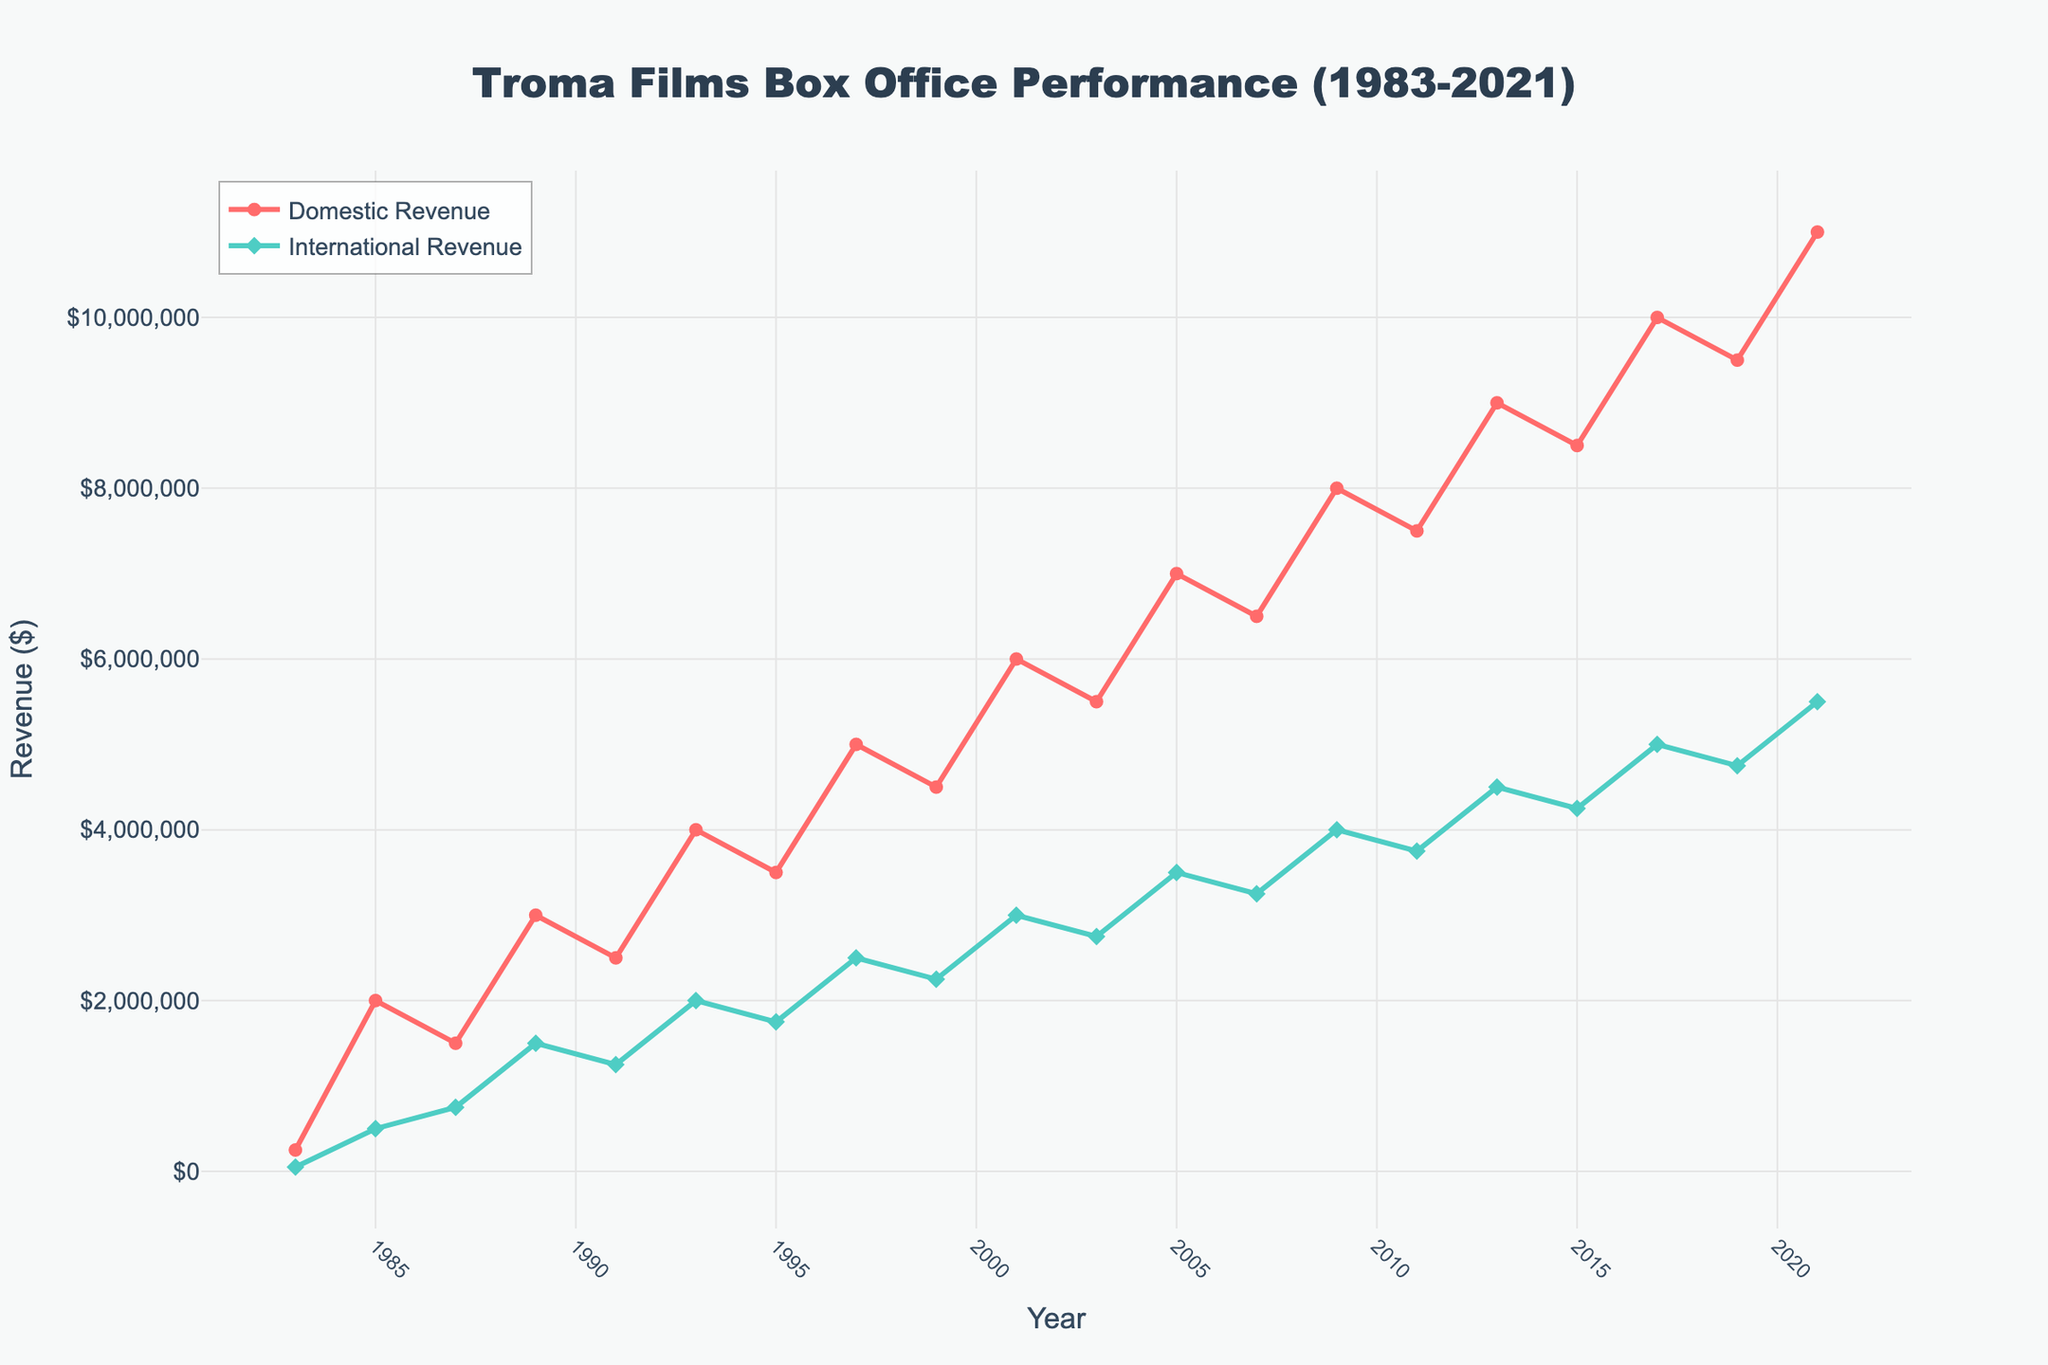What years show a significant increase in both Domestic and International revenues? To identify years with significant increases in both Domestic and International revenues, we need to compare the changes between consecutive years. From the figure, the years 1983-1985, 2001-2003, and 2007-2009 show significant increases. For instance, Domestic revenue increased from $200,000 to $2,000,000 and International revenue from $50,000 to $500,000 between 1983 and 1985.
Answer: 1983-1985, 2001-2003, 2007-2009 Which year had the highest domestic revenue, and what was the amount? To determine the year with the highest domestic revenue, we look for the peak value on the Domestic Revenue line. The highest point is in 2021 with a revenue of $11,000,000.
Answer: 2021, $11,000,000 Between what years was the growth in International revenue the most substantial? To find the period of the most significant growth in International revenue, we examine the steepest increase on the International Revenue line. This occurs between 2019 and 2021, where revenue increased from $4,750,000 to $5,500,000, a $750,000 increase.
Answer: 2019-2021 What is the approximate overall trend of the Domestic Revenue over the 40 years? The overall trend can be inferred by observing the shape and direction of the Domestic Revenue line. Starting from a lower value in 1983, it generally shows an upward trend with fluctuations reaching the peak in 2021.
Answer: Upward trend with fluctuations How does the Domestic Revenue compare to the International Revenue in 2017? To compare the revenues for 2017, we check the values for both lines in that year. The Domestic Revenue in 2017 was $10,000,000, while the International Revenue was $5,000,000. Thus, the Domestic Revenue was higher than the International Revenue by $5,000,000.
Answer: Domestic Revenue is higher by $5,000,000 From domestic and international figures, in which year did both revenues hit the mid-point of their respective ranges simultaneously? To identify the year when both revenues hit the mid-point, we need to find the corresponding middle values for each line. These ranges are $250,000 to $11,000,000 for Domestic and $50,000 to $5,500,000 for International. Calculating mid-points (average of min and max), we get: Domestic mid-point = ($250,000 + $11,000,000) / 2 = $5,625,000 and International mid-point = ($50,000 + $5,500,000) / 2 = $2,775,000. Visually, both lines approximate these mid-points around the year 2007.
Answer: 2007 What are the average domestic and international revenues over the entire period? The average for each revenue type is calculated by summing up all values and dividing by the number of years. Summing Domestic Revenues and International Revenues (sum obtained): Domestic = $500,000 +...+ $11,000,000 = $97,750,000 and International = $50,000 +...+ $5,500,000 = $46,1250,000. Divide by 20 years (total data points): Average Domestic = $97,750,000 / 20 = $4,887,500, Average International = $46,1250,000 / 20 = $2,306,250.
Answer: $4,887,500 for Domestic, $2,306,250 for International 